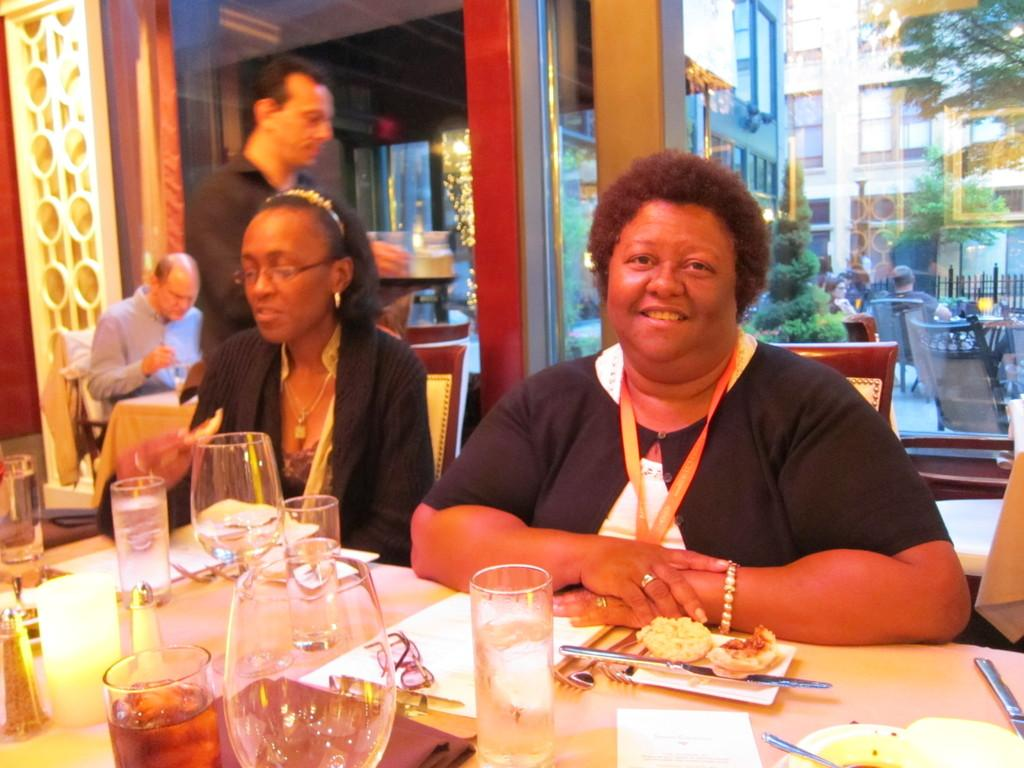How many women are sitting on the chair in the image? There are two women sitting on a chair in the image. What is in front of the women? The women are in front of a table. What is happening behind the women? A man is walking behind the women. What type of natural environment can be seen in the image? There are trees visible in the image. What can be seen through the window in the image? There is a building visible through a window. What type of quiver is the man carrying in the image? There is no quiver present in the image; the man is simply walking behind the women. 